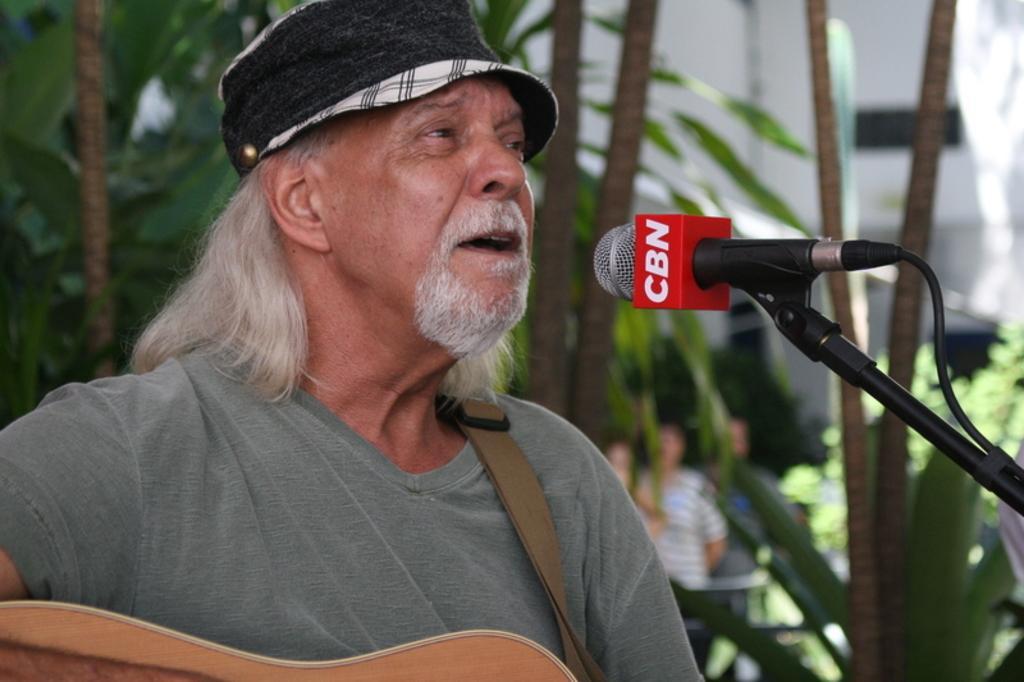Could you give a brief overview of what you see in this image? The person wearing a hat is playing guitar in front of a mic and there are trees in the background. 